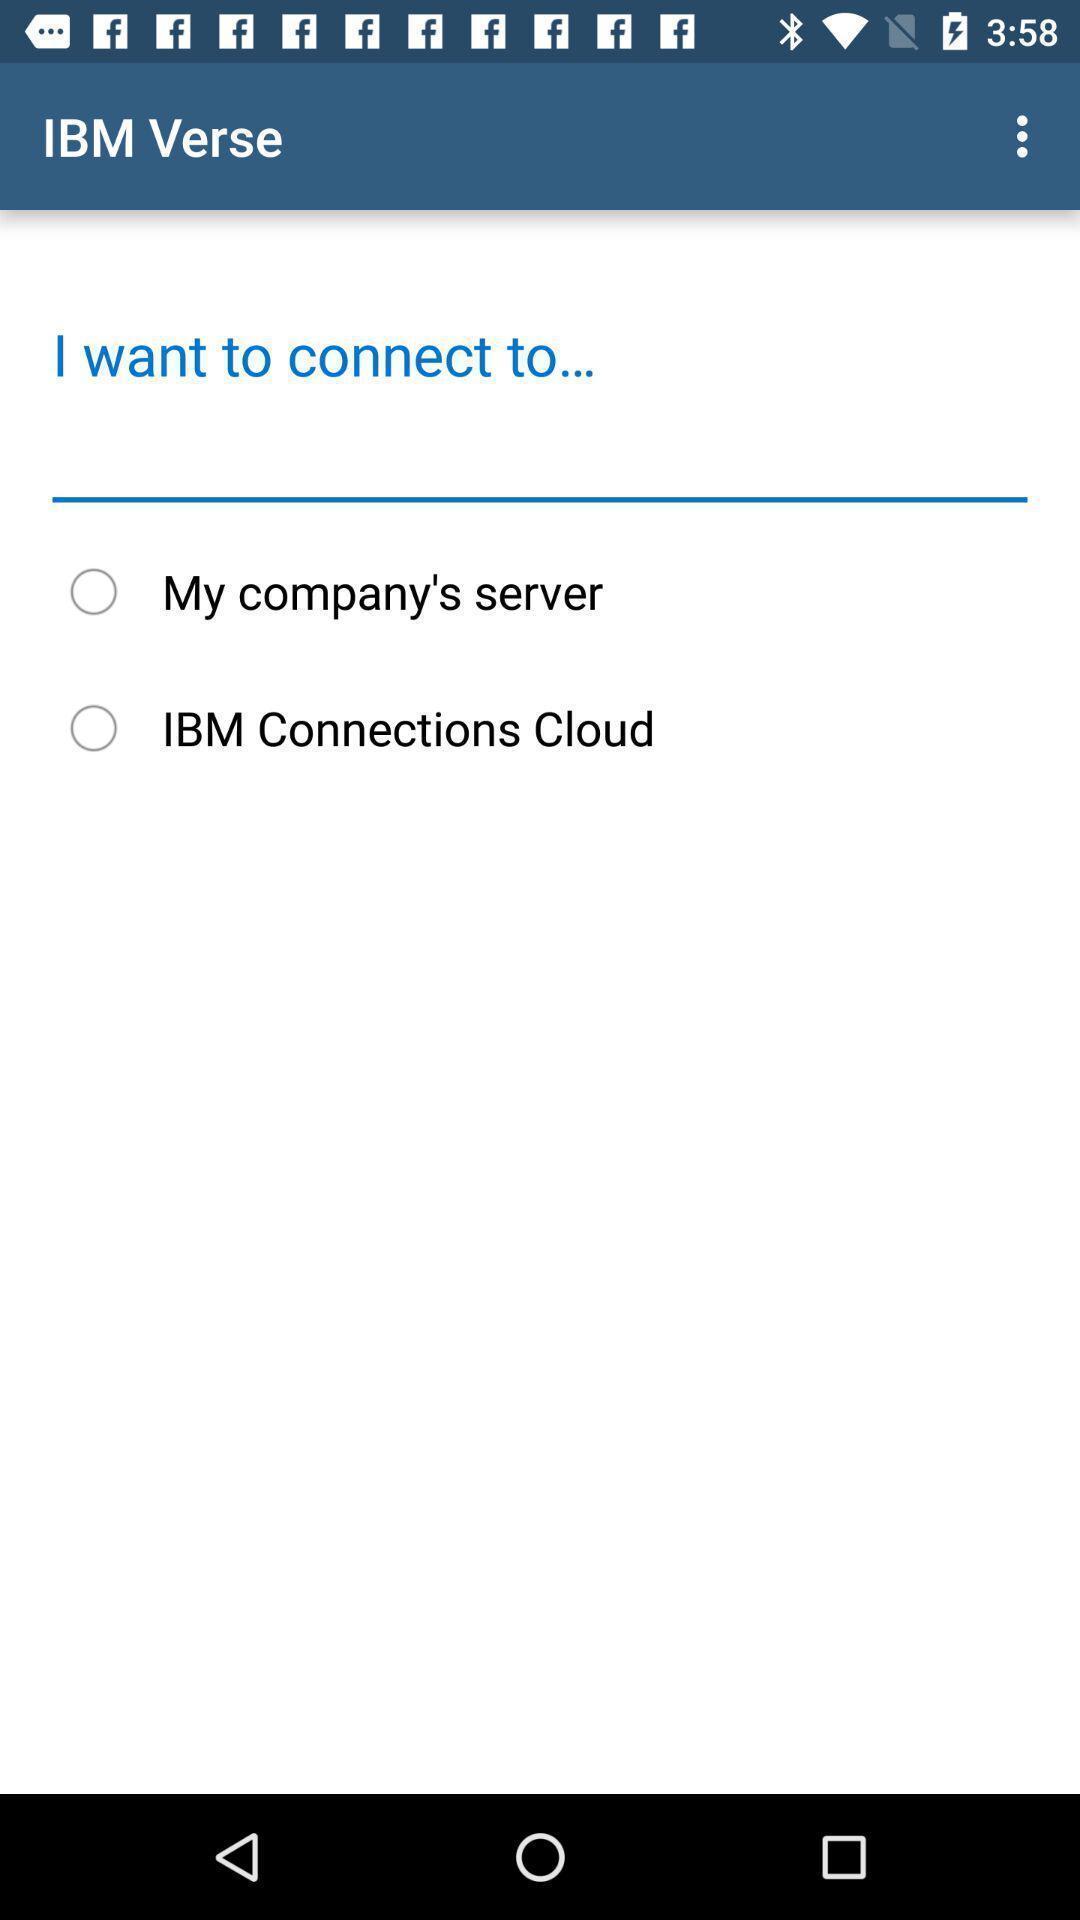Give me a narrative description of this picture. Welcome page of an organization app. 